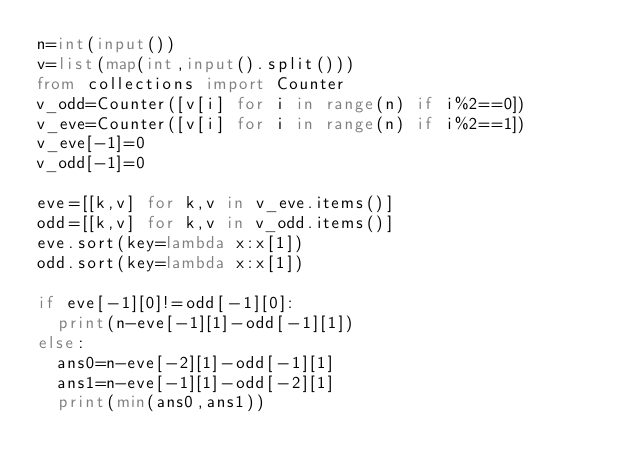<code> <loc_0><loc_0><loc_500><loc_500><_Python_>n=int(input())
v=list(map(int,input().split()))
from collections import Counter
v_odd=Counter([v[i] for i in range(n) if i%2==0])
v_eve=Counter([v[i] for i in range(n) if i%2==1])
v_eve[-1]=0
v_odd[-1]=0

eve=[[k,v] for k,v in v_eve.items()]
odd=[[k,v] for k,v in v_odd.items()]
eve.sort(key=lambda x:x[1])
odd.sort(key=lambda x:x[1])

if eve[-1][0]!=odd[-1][0]:
  print(n-eve[-1][1]-odd[-1][1])
else:
  ans0=n-eve[-2][1]-odd[-1][1]
  ans1=n-eve[-1][1]-odd[-2][1]
  print(min(ans0,ans1))</code> 